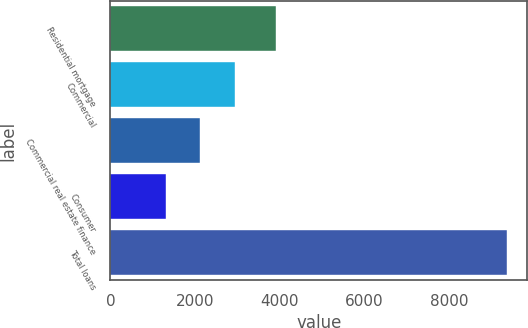<chart> <loc_0><loc_0><loc_500><loc_500><bar_chart><fcel>Residential mortgage<fcel>Commercial<fcel>Commercial real estate finance<fcel>Consumer<fcel>Total loans<nl><fcel>3900.1<fcel>2931.38<fcel>2126.34<fcel>1321.3<fcel>9371.7<nl></chart> 